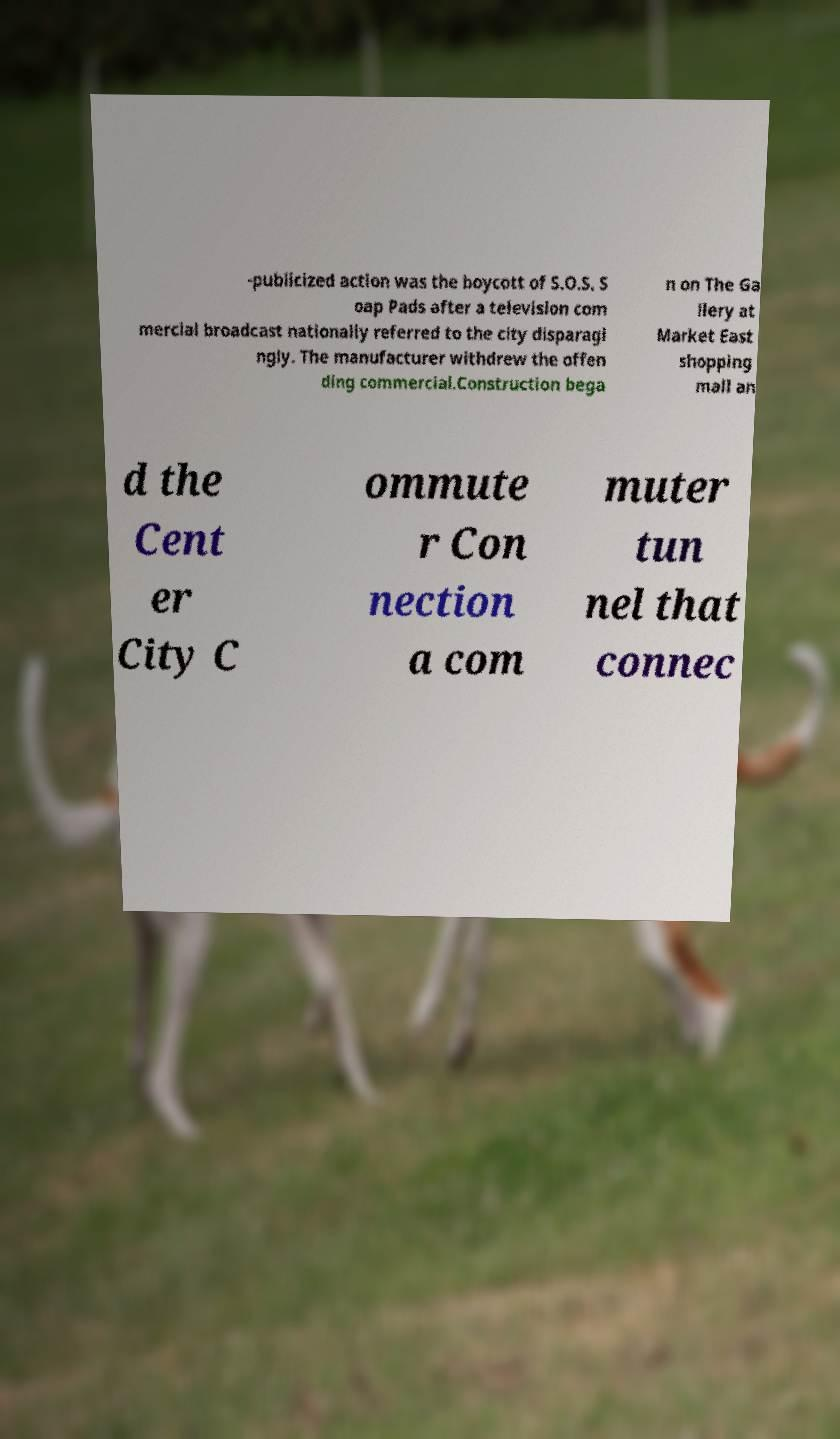I need the written content from this picture converted into text. Can you do that? -publicized action was the boycott of S.O.S. S oap Pads after a television com mercial broadcast nationally referred to the city disparagi ngly. The manufacturer withdrew the offen ding commercial.Construction bega n on The Ga llery at Market East shopping mall an d the Cent er City C ommute r Con nection a com muter tun nel that connec 